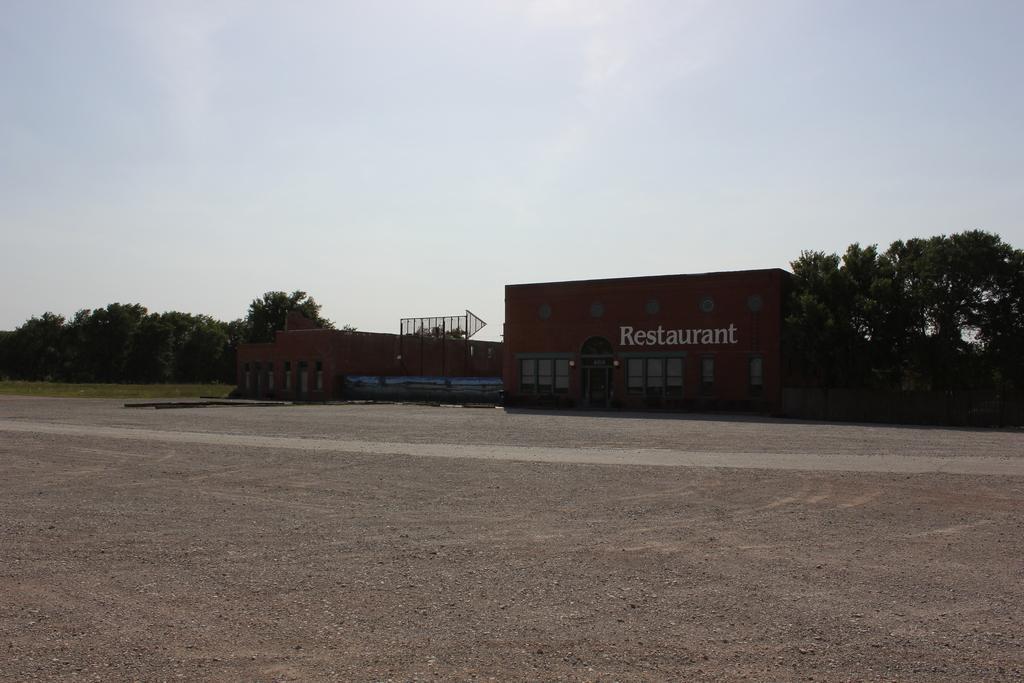Can you describe this image briefly? In this image we can see houses, there are text on the wall, also we can see the sky, and trees. 